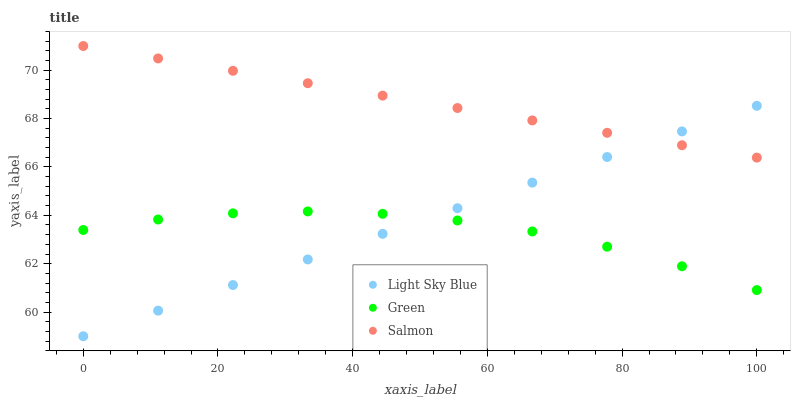Does Green have the minimum area under the curve?
Answer yes or no. Yes. Does Salmon have the maximum area under the curve?
Answer yes or no. Yes. Does Light Sky Blue have the minimum area under the curve?
Answer yes or no. No. Does Light Sky Blue have the maximum area under the curve?
Answer yes or no. No. Is Salmon the smoothest?
Answer yes or no. Yes. Is Green the roughest?
Answer yes or no. Yes. Is Light Sky Blue the smoothest?
Answer yes or no. No. Is Light Sky Blue the roughest?
Answer yes or no. No. Does Light Sky Blue have the lowest value?
Answer yes or no. Yes. Does Green have the lowest value?
Answer yes or no. No. Does Salmon have the highest value?
Answer yes or no. Yes. Does Light Sky Blue have the highest value?
Answer yes or no. No. Is Green less than Salmon?
Answer yes or no. Yes. Is Salmon greater than Green?
Answer yes or no. Yes. Does Light Sky Blue intersect Green?
Answer yes or no. Yes. Is Light Sky Blue less than Green?
Answer yes or no. No. Is Light Sky Blue greater than Green?
Answer yes or no. No. Does Green intersect Salmon?
Answer yes or no. No. 